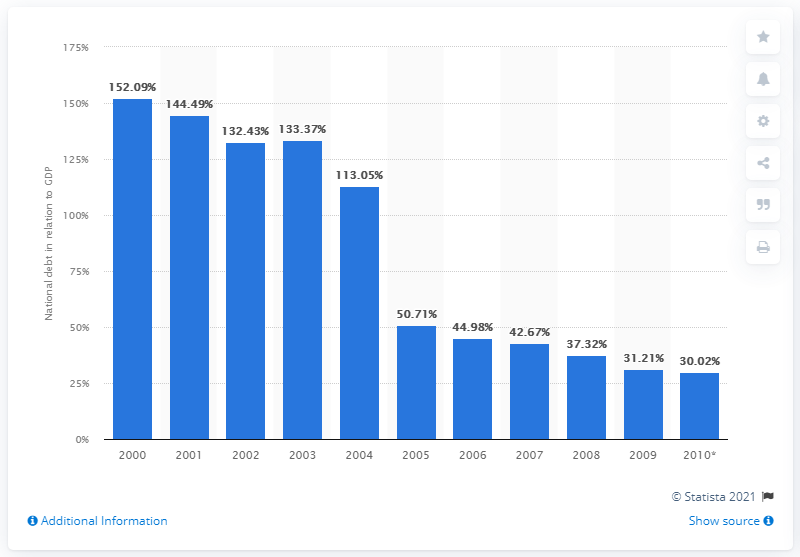Give some essential details in this illustration. In 2010, Syria's national debt accounted for approximately 30.02% of the country's GDP. 